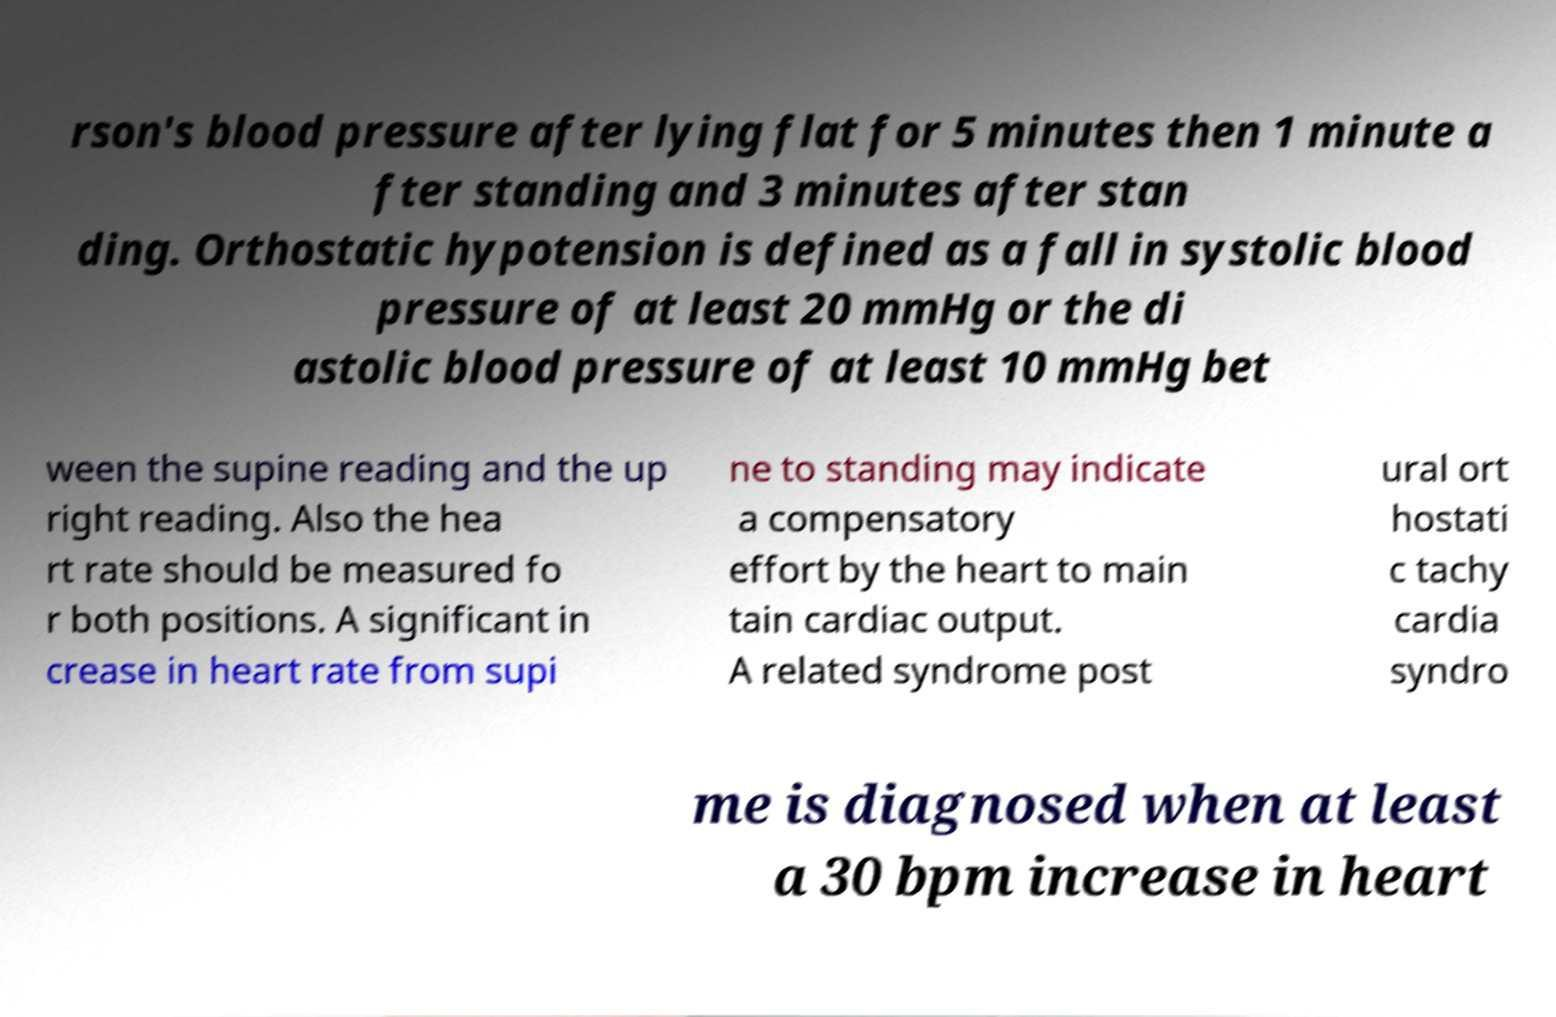What messages or text are displayed in this image? I need them in a readable, typed format. rson's blood pressure after lying flat for 5 minutes then 1 minute a fter standing and 3 minutes after stan ding. Orthostatic hypotension is defined as a fall in systolic blood pressure of at least 20 mmHg or the di astolic blood pressure of at least 10 mmHg bet ween the supine reading and the up right reading. Also the hea rt rate should be measured fo r both positions. A significant in crease in heart rate from supi ne to standing may indicate a compensatory effort by the heart to main tain cardiac output. A related syndrome post ural ort hostati c tachy cardia syndro me is diagnosed when at least a 30 bpm increase in heart 